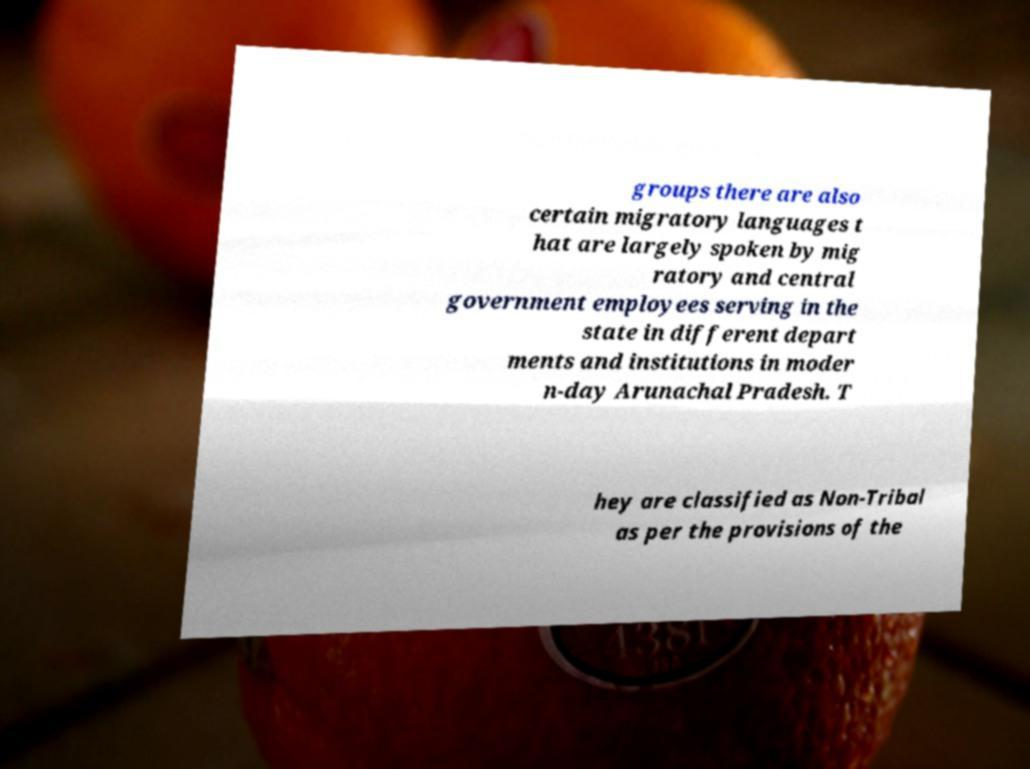Could you extract and type out the text from this image? groups there are also certain migratory languages t hat are largely spoken by mig ratory and central government employees serving in the state in different depart ments and institutions in moder n-day Arunachal Pradesh. T hey are classified as Non-Tribal as per the provisions of the 